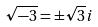<formula> <loc_0><loc_0><loc_500><loc_500>\sqrt { - 3 } = \pm \sqrt { 3 } i</formula> 